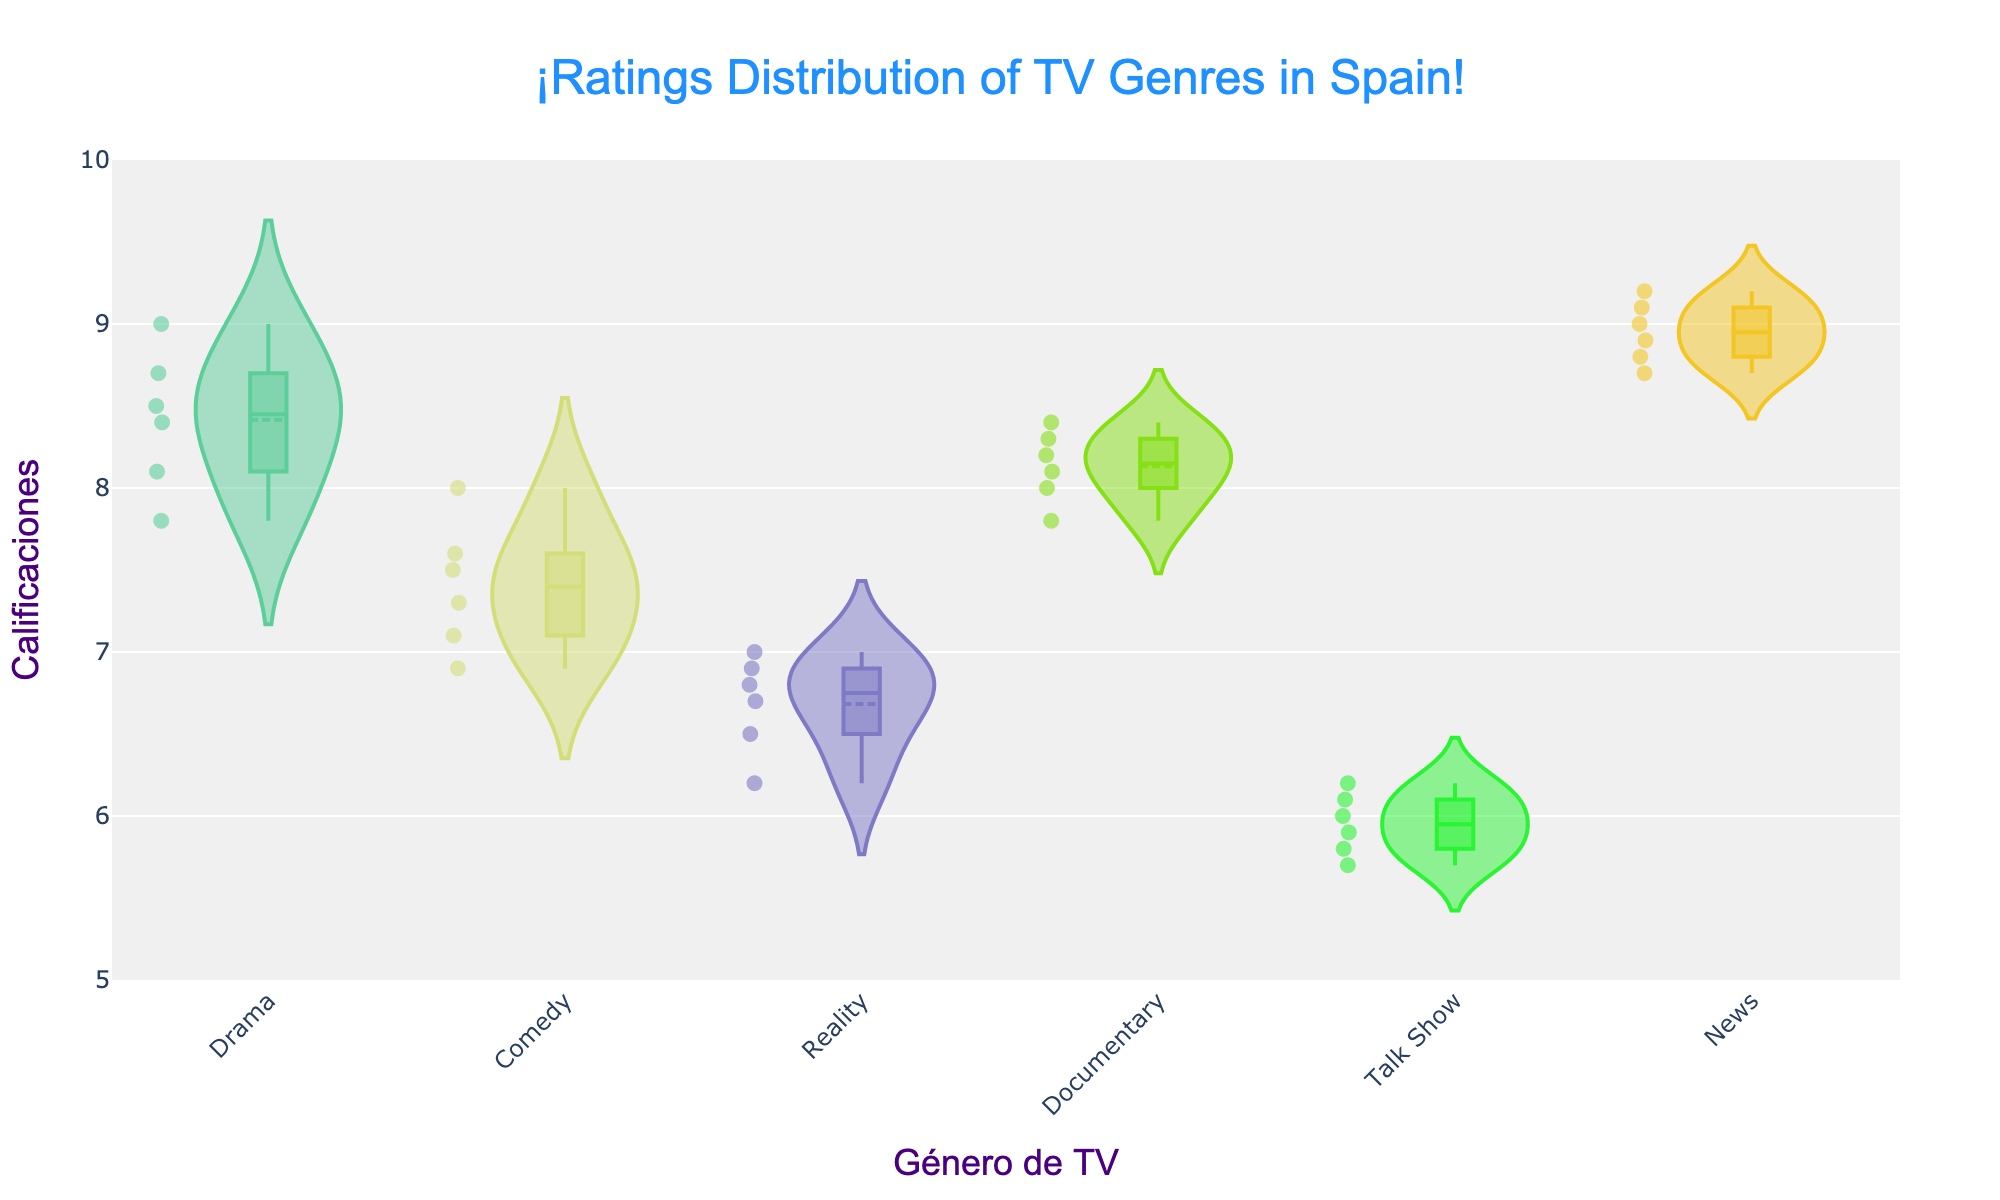What is the title of the chart? The title is usually in a prominent place at the top of the chart. In this case, it's centered at the top.
Answer: ¡Ratings Distribution of TV Genres in Spain! Which genre in the chart has the highest average rating? Looking at the meanline, the genre with the highest mean rating is noticeable.
Answer: News How do the ratings for Drama compare to those for Comedy in terms of spread? By examining the width of the violins and the distribution of data points, you can see Drama's ratings are slightly more spread out than Comedy’s.
Answer: Drama is more spread out What is the range of ratings for Reality shows? The range can be observed from the lowest to the highest point in the Reality violin plot.
Answer: 6.2 to 7.0 Which genre has the lowest median rating? The median is the middle line in the box plot part of the violin. The genre with the lowest median line is noteworthy.
Answer: Talk Show How does the spread of ratings for News compare to that for Documentary? Comparing the width and distribution of the two violin plots, you can see that News has a tighter spread.
Answer: News is tighter Which genre has the widest spread of ratings? The genre with the widest violin plot from bottom to top can be determined by examining all the violins.
Answer: Drama What is the average rating for the Talk Show genre? The average (mean) rating is marked by the mean line in the violin plot for Talk Show.
Answer: 5.95 How many data points are there for each genre? Counting the small points within each violin plot for each genre gives you the number of ratings recorded.
Answer: Drama: 6, Comedy: 6, Reality: 6, Documentary: 6, Talk Show: 6, News: 6 For which genres are individual ratings most similar to each other? Regions where the data are tightly clustered and the violin plot is narrower reflect more similar ratings.
Answer: News and Talk Show 